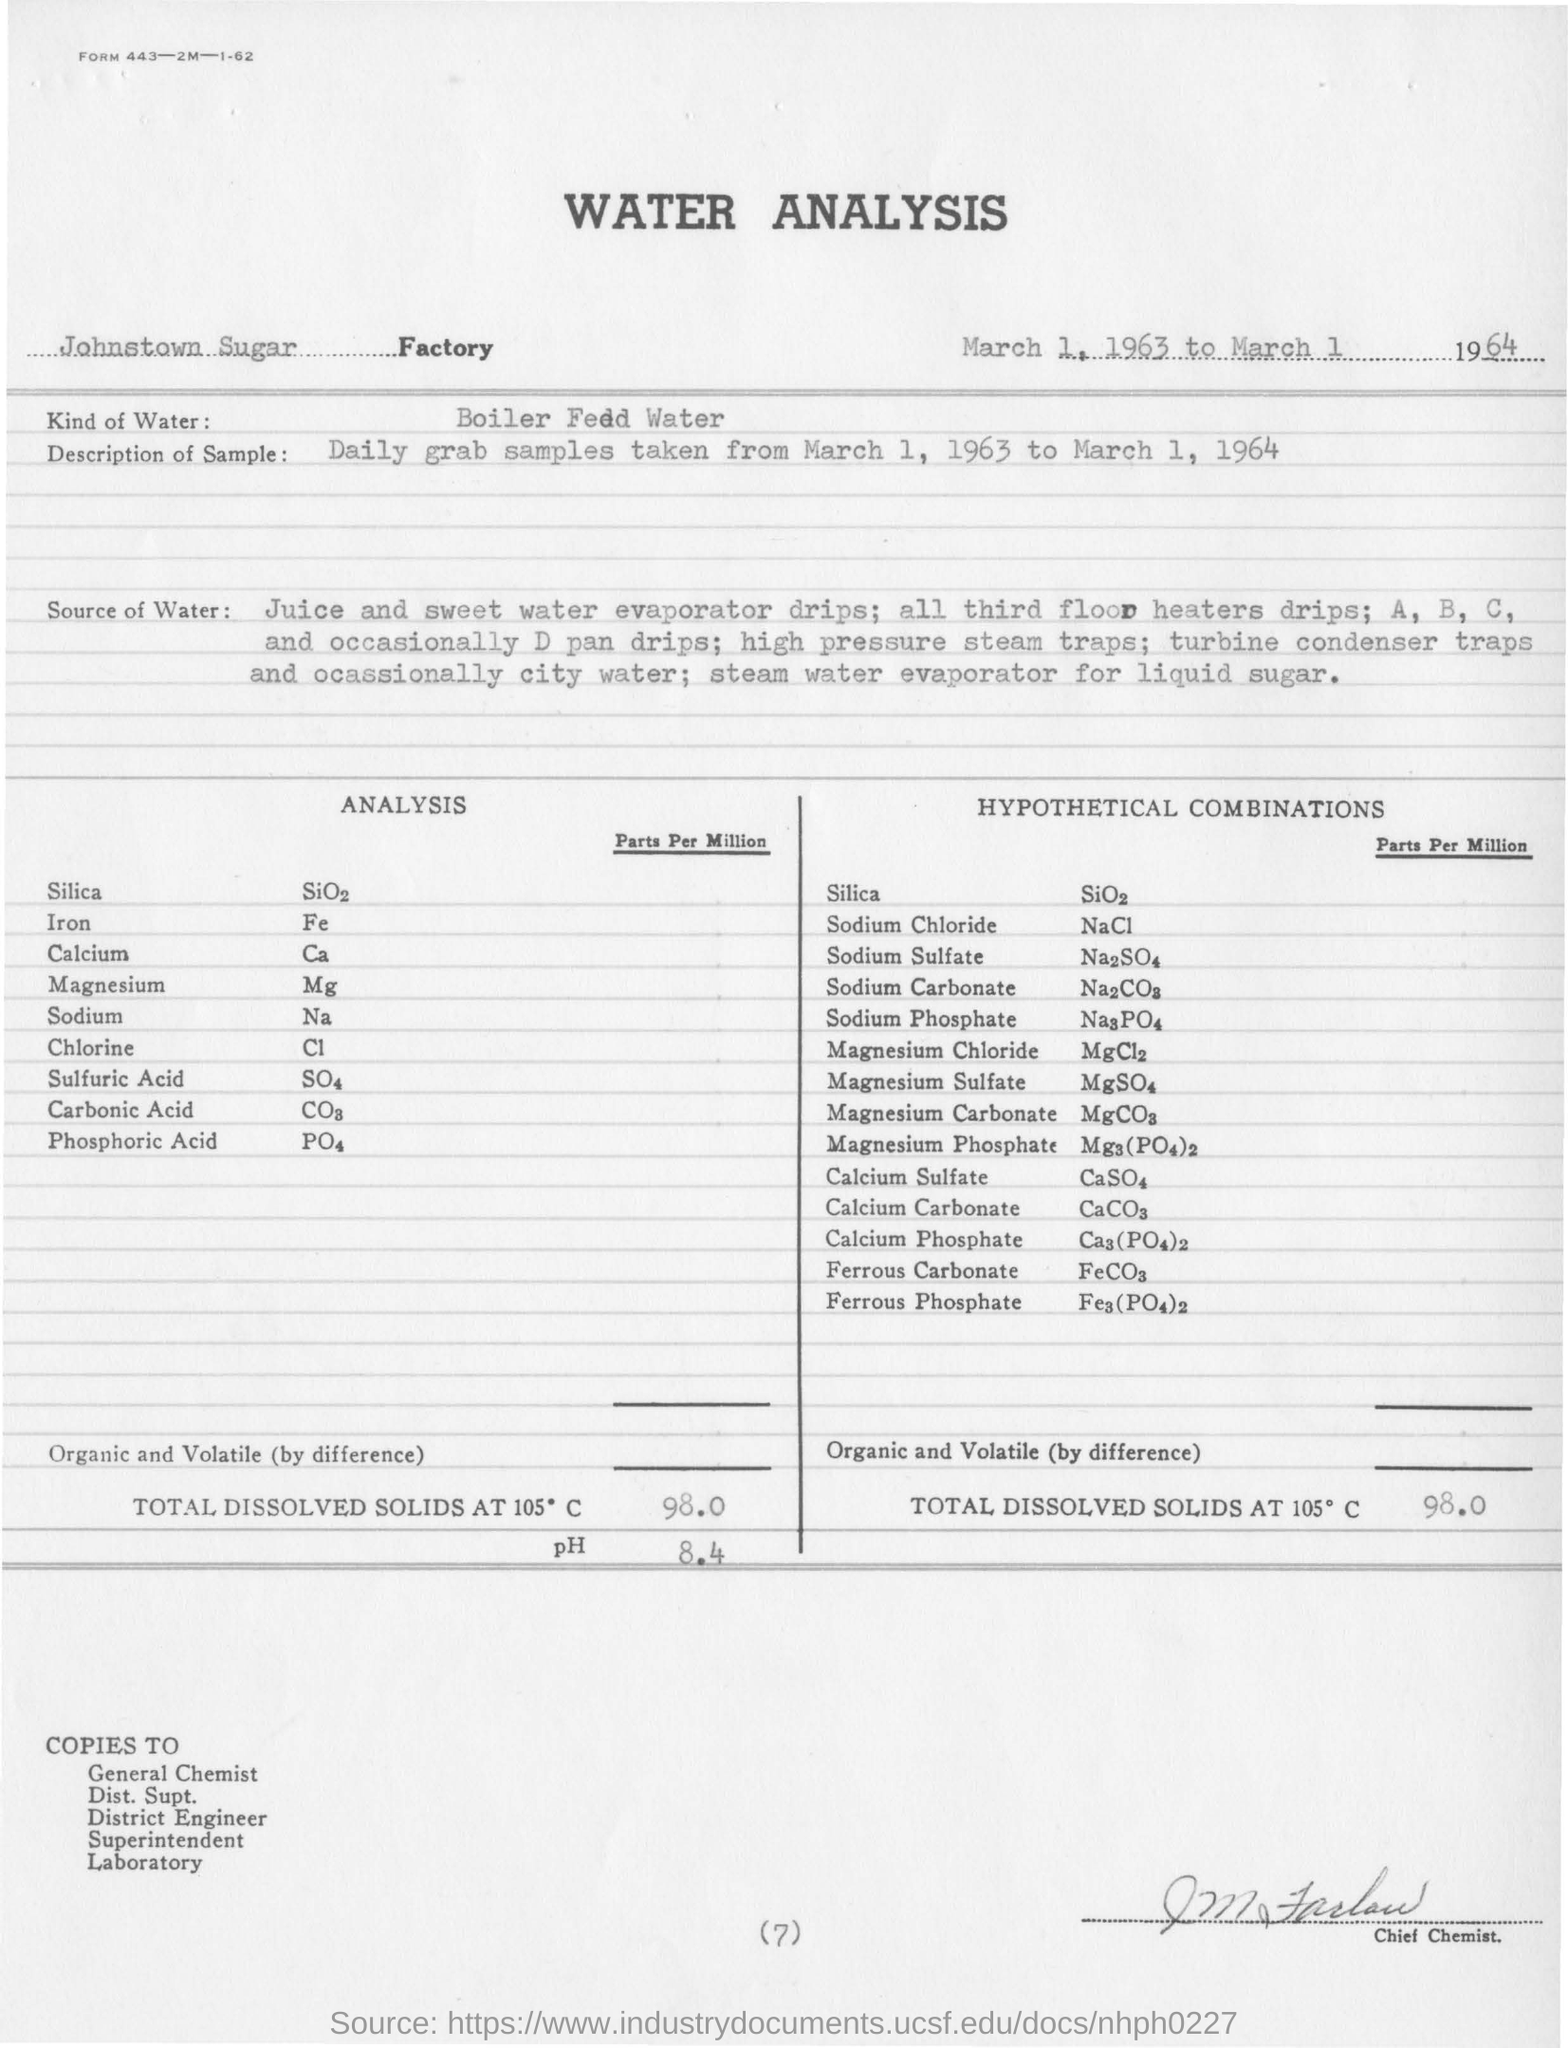What is the title of the document?
Provide a short and direct response. Water Analysis. What is the formula of Silica?
Give a very brief answer. SiO2. What is the symbol of Calcium?
Ensure brevity in your answer.  Ca. What is the total dissolved solids at 150 degree celsius?
Give a very brief answer. 98. 